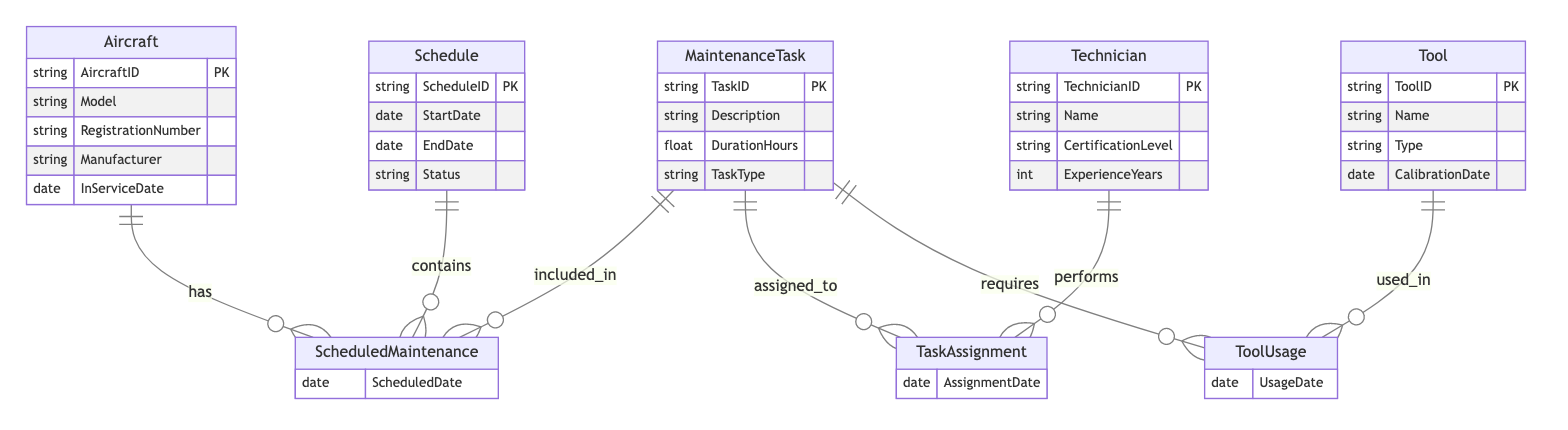What's the primary key of the Aircraft entity? The primary key of the Aircraft entity is AircraftID, which uniquely identifies each aircraft in the system.
Answer: AircraftID How many entities are present in the diagram? The diagram includes five distinct entities: Aircraft, MaintenanceTask, Schedule, Technician, and Tool. Counting these gives a total of five entities.
Answer: Five What relationship connects MaintenanceTask and Technician? The relationship connecting MaintenanceTask and Technician is called TaskAssignment, which signifies which technician is assigned to perform a specific maintenance task.
Answer: TaskAssignment What attributes are associated with the ScheduledMaintenance relationship? The ScheduledMaintenance relationship has one attribute, which is ScheduledDate, indicating the date when the maintenance is scheduled for an aircraft.
Answer: ScheduledDate How many attributes does the Technician entity have? The Technician entity has four attributes: TechnicianID, Name, CertificationLevel, and ExperienceYears, contributing to the overall details of a technician.
Answer: Four What does the ToolUsage relationship indicate? The ToolUsage relationship indicates which tools are used in the context of specific MaintenanceTasks. It connects the Tool entity with the MaintenanceTask entity.
Answer: ToolUsage If a Technician has 10 years of experience, can they perform all MaintenanceTasks? The performability of all MaintenanceTasks by a Technician depends on their CertificationLevel, as some tasks may require specific certifications beyond just experience.
Answer: No Which entity requires the UsageDate attribute in the diagram? The UsageDate attribute is required by the ToolUsage relationship, which tracks when a specific tool was used in relation to a maintenance task.
Answer: ToolUsage How many MaintenanceTasks can be linked to a single Aircraft in the ScheduledMaintenance relationship? There is no defined limit on the number of MaintenanceTasks that can be linked to a single Aircraft within the ScheduledMaintenance relationship; theoretically, it can be many.
Answer: Many 